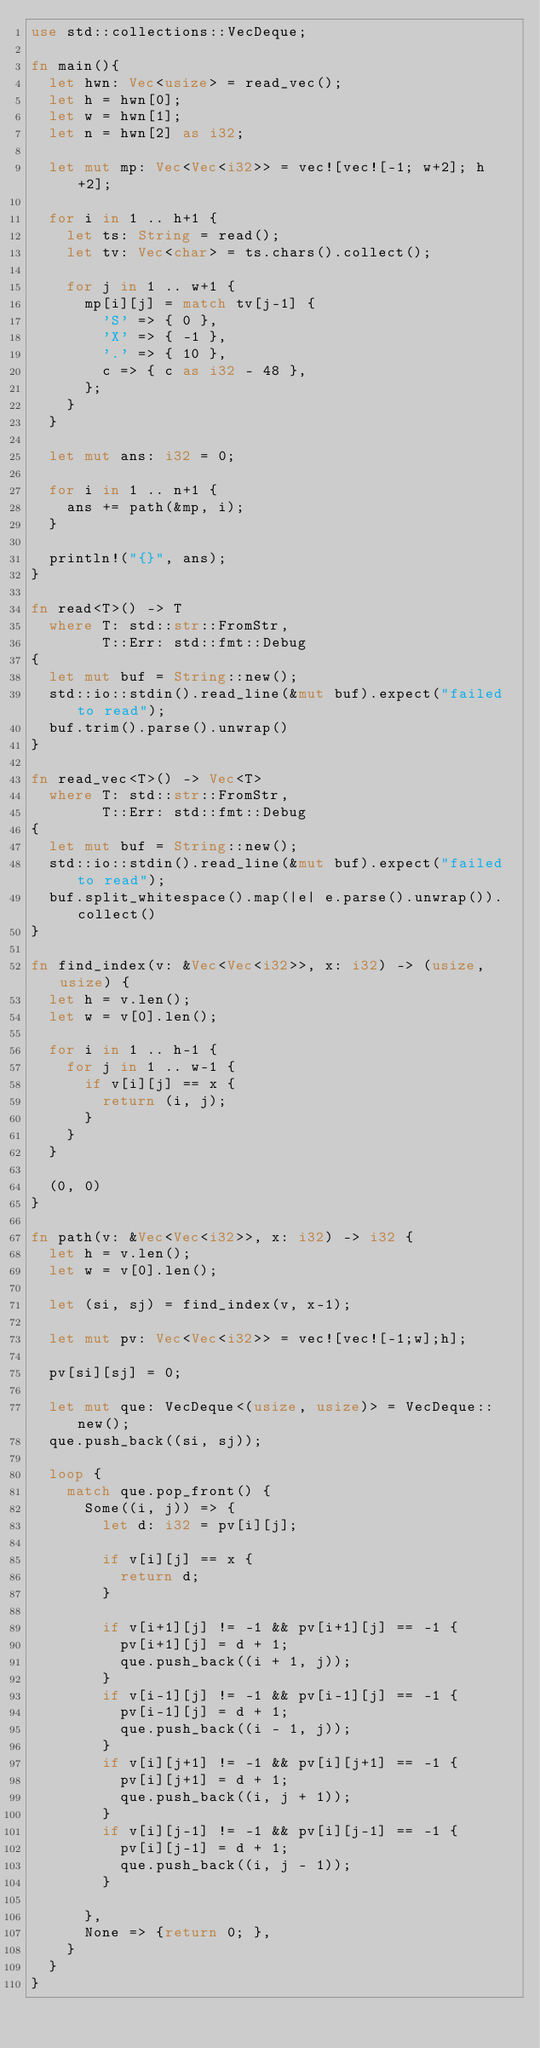<code> <loc_0><loc_0><loc_500><loc_500><_Rust_>use std::collections::VecDeque;

fn main(){
  let hwn: Vec<usize> = read_vec();
  let h = hwn[0];
  let w = hwn[1];
  let n = hwn[2] as i32;

  let mut mp: Vec<Vec<i32>> = vec![vec![-1; w+2]; h+2];
  
  for i in 1 .. h+1 {
    let ts: String = read();
    let tv: Vec<char> = ts.chars().collect();
    
    for j in 1 .. w+1 {
      mp[i][j] = match tv[j-1] {
        'S' => { 0 },
        'X' => { -1 },
        '.' => { 10 },
        c => { c as i32 - 48 },
      };
    }
  }

  let mut ans: i32 = 0;
  
  for i in 1 .. n+1 {
    ans += path(&mp, i);
  }
  
  println!("{}", ans);
}

fn read<T>() -> T
  where T: std::str::FromStr,
        T::Err: std::fmt::Debug
{
  let mut buf = String::new();
  std::io::stdin().read_line(&mut buf).expect("failed to read");
  buf.trim().parse().unwrap()
}

fn read_vec<T>() -> Vec<T>
  where T: std::str::FromStr,
        T::Err: std::fmt::Debug
{
  let mut buf = String::new();
  std::io::stdin().read_line(&mut buf).expect("failed to read");
  buf.split_whitespace().map(|e| e.parse().unwrap()).collect()
}

fn find_index(v: &Vec<Vec<i32>>, x: i32) -> (usize, usize) {
  let h = v.len();
  let w = v[0].len();
  
  for i in 1 .. h-1 {
    for j in 1 .. w-1 {
      if v[i][j] == x {
        return (i, j);
      }
    }
  }
  
  (0, 0)
}

fn path(v: &Vec<Vec<i32>>, x: i32) -> i32 {
  let h = v.len();
  let w = v[0].len();
  
  let (si, sj) = find_index(v, x-1);

  let mut pv: Vec<Vec<i32>> = vec![vec![-1;w];h];

  pv[si][sj] = 0;

  let mut que: VecDeque<(usize, usize)> = VecDeque::new();
  que.push_back((si, sj));

  loop {
    match que.pop_front() {
      Some((i, j)) => {
        let d: i32 = pv[i][j];
        
        if v[i][j] == x {
          return d;
        }

        if v[i+1][j] != -1 && pv[i+1][j] == -1 {
          pv[i+1][j] = d + 1;
          que.push_back((i + 1, j));
        }
        if v[i-1][j] != -1 && pv[i-1][j] == -1 {
          pv[i-1][j] = d + 1;
          que.push_back((i - 1, j));
        }
        if v[i][j+1] != -1 && pv[i][j+1] == -1 {
          pv[i][j+1] = d + 1;
          que.push_back((i, j + 1));
        }
        if v[i][j-1] != -1 && pv[i][j-1] == -1 {
          pv[i][j-1] = d + 1;
          que.push_back((i, j - 1));
        }
        
      },
      None => {return 0; },
    }
  }
}

</code> 